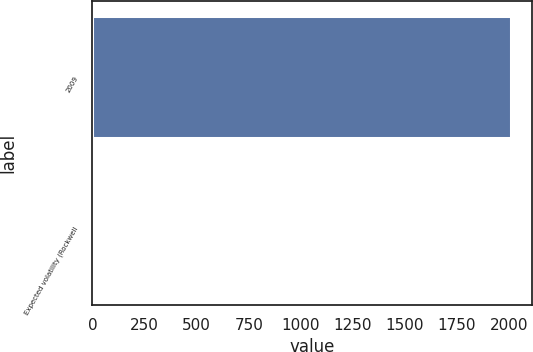Convert chart to OTSL. <chart><loc_0><loc_0><loc_500><loc_500><bar_chart><fcel>2009<fcel>Expected volatility (Rockwell<nl><fcel>2008<fcel>0.27<nl></chart> 